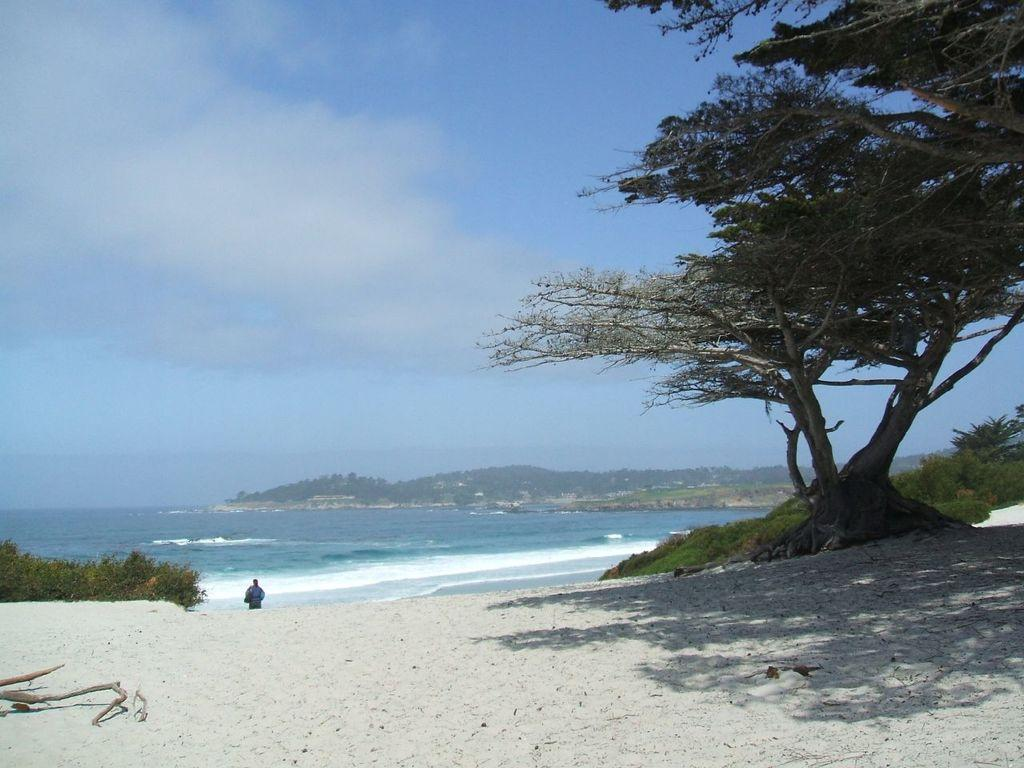What type of natural elements can be seen in the image? Plants, trees, mountains, and the ocean are visible in the image. Are there any man-made structures present in the image? No specific man-made structures are mentioned, but there is a person in the image. What part of the natural environment is visible in the image? The ocean and the sky are visible in the image. What type of house can be seen in the image? There is no house present in the image; it features natural elements such as plants, trees, mountains, and the ocean. What type of journey is the person in the image taking? There is no indication of a journey in the image; it simply shows a person amidst natural surroundings. 